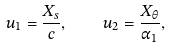Convert formula to latex. <formula><loc_0><loc_0><loc_500><loc_500>u _ { 1 } = \frac { X _ { s } } { c } , \quad u _ { 2 } = \frac { X _ { \theta } } { \alpha _ { 1 } } ,</formula> 